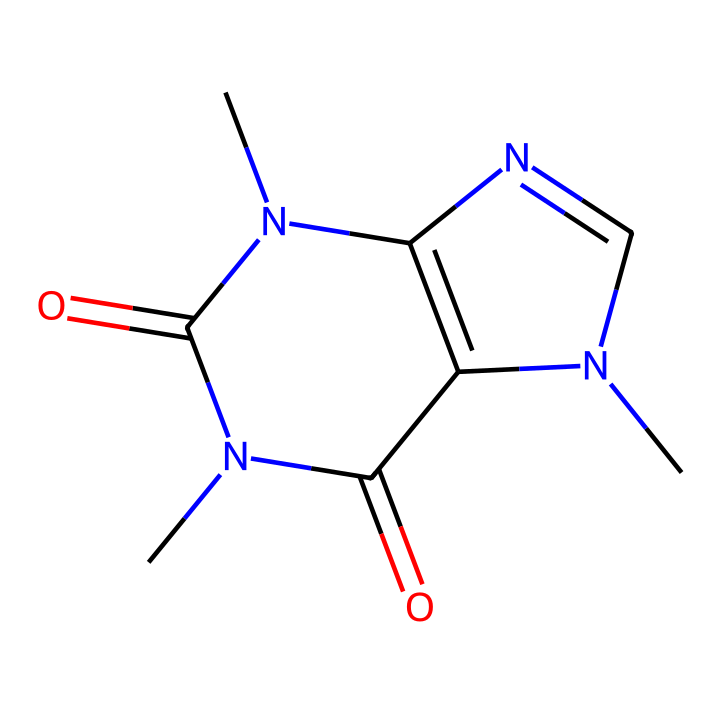What is the chemical name of this compound? The SMILES representation corresponds to caffeine, which is a well-known stimulant. By analyzing the structure represented, we recognize the presence of a specific arrangement that is characteristic of caffeine.
Answer: caffeine How many nitrogen atoms are present in this structure? By examining the SMILES representation, we identify four nitrogen atoms in the structure. Each nitrogen (N) can be counted directly from the chemical formula.
Answer: four What type of functional groups can be identified in this compound? The structure contains imide functional groups, characterized by the presence of carbonyl groups (C=O) attached to nitrogen atoms. Since the structure has multiple nitrogen atoms adjacent to carbonyls, it indicates the presence of imide groups.
Answer: imide Do the nitrogen atoms indicate this compound is an alkaloid? Yes, the multiple nitrogen atoms present in caffeine's structure signify that it is an alkaloid, as alkaloids are typically nitrogen-containing compounds. This understanding combines the nature of nitrogen with the classification of caffeine.
Answer: yes How many carbonyl (C=O) groups are there in this molecule? The structure shows that there are two carbonyl groups evident in the arrangement. Each carbonyl group corresponds to a specific carbon atom double-bonded to oxygen that can be counted in the chemical structure.
Answer: two Is caffeine a type of imide? Yes, caffeine belongs to the imide classification because of its specific arrangement of nitrogen atoms adjacent to carbonyl groups. This structural feature is fundamental to defining imides.
Answer: yes 